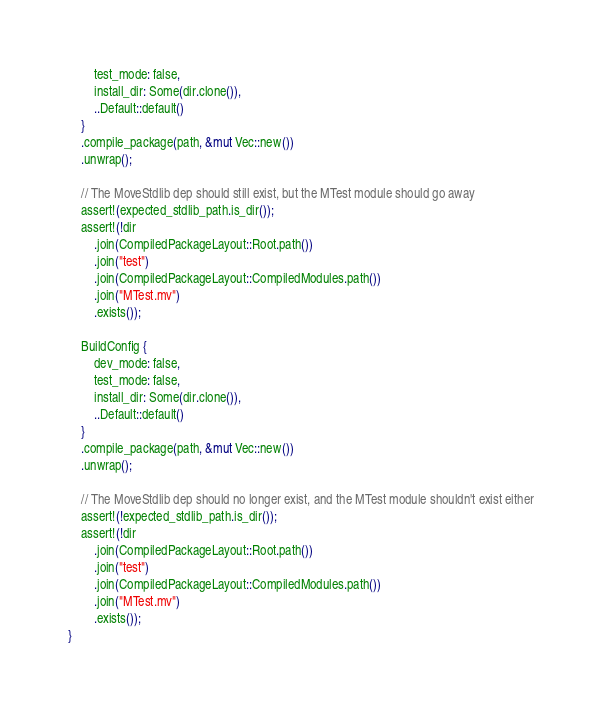<code> <loc_0><loc_0><loc_500><loc_500><_Rust_>        test_mode: false,
        install_dir: Some(dir.clone()),
        ..Default::default()
    }
    .compile_package(path, &mut Vec::new())
    .unwrap();

    // The MoveStdlib dep should still exist, but the MTest module should go away
    assert!(expected_stdlib_path.is_dir());
    assert!(!dir
        .join(CompiledPackageLayout::Root.path())
        .join("test")
        .join(CompiledPackageLayout::CompiledModules.path())
        .join("MTest.mv")
        .exists());

    BuildConfig {
        dev_mode: false,
        test_mode: false,
        install_dir: Some(dir.clone()),
        ..Default::default()
    }
    .compile_package(path, &mut Vec::new())
    .unwrap();

    // The MoveStdlib dep should no longer exist, and the MTest module shouldn't exist either
    assert!(!expected_stdlib_path.is_dir());
    assert!(!dir
        .join(CompiledPackageLayout::Root.path())
        .join("test")
        .join(CompiledPackageLayout::CompiledModules.path())
        .join("MTest.mv")
        .exists());
}
</code> 